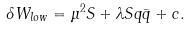<formula> <loc_0><loc_0><loc_500><loc_500>\delta W _ { l o w } = \mu ^ { 2 } S + \lambda S q \bar { q } + c .</formula> 